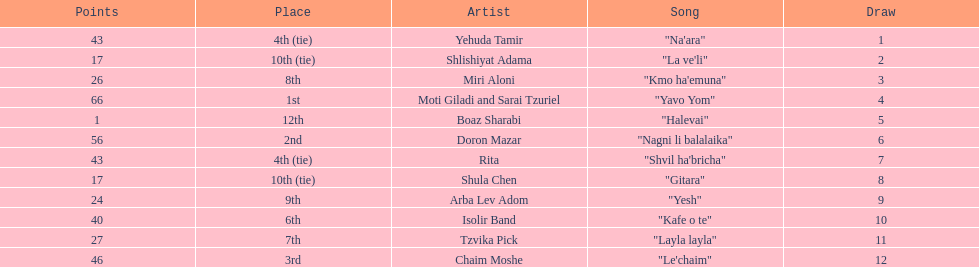Parse the full table. {'header': ['Points', 'Place', 'Artist', 'Song', 'Draw'], 'rows': [['43', '4th (tie)', 'Yehuda Tamir', '"Na\'ara"', '1'], ['17', '10th (tie)', 'Shlishiyat Adama', '"La ve\'li"', '2'], ['26', '8th', 'Miri Aloni', '"Kmo ha\'emuna"', '3'], ['66', '1st', 'Moti Giladi and Sarai Tzuriel', '"Yavo Yom"', '4'], ['1', '12th', 'Boaz Sharabi', '"Halevai"', '5'], ['56', '2nd', 'Doron Mazar', '"Nagni li balalaika"', '6'], ['43', '4th (tie)', 'Rita', '"Shvil ha\'bricha"', '7'], ['17', '10th (tie)', 'Shula Chen', '"Gitara"', '8'], ['24', '9th', 'Arba Lev Adom', '"Yesh"', '9'], ['40', '6th', 'Isolir Band', '"Kafe o te"', '10'], ['27', '7th', 'Tzvika Pick', '"Layla layla"', '11'], ['46', '3rd', 'Chaim Moshe', '"Le\'chaim"', '12']]} Doron mazar, which artist(s) had the most points? Moti Giladi and Sarai Tzuriel. 